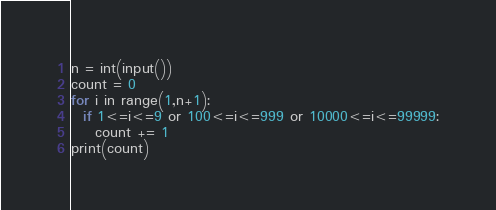Convert code to text. <code><loc_0><loc_0><loc_500><loc_500><_Python_>n = int(input())
count = 0
for i in range(1,n+1):
  if 1<=i<=9 or 100<=i<=999 or 10000<=i<=99999:
    count += 1
print(count)</code> 